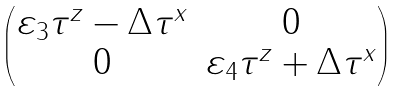<formula> <loc_0><loc_0><loc_500><loc_500>\begin{pmatrix} \varepsilon _ { 3 } \tau ^ { z } - \Delta \tau ^ { x } & 0 \\ 0 & \varepsilon _ { 4 } \tau ^ { z } + \Delta \tau ^ { x } \end{pmatrix}</formula> 